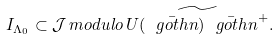<formula> <loc_0><loc_0><loc_500><loc_500>I _ { \Lambda _ { 0 } } \subset { \mathcal { J } } \, m o d u l o \, \widetilde { U ( \bar { \ g o t h { n } } ) \bar { \ g o t h { n } } ^ { + } } .</formula> 